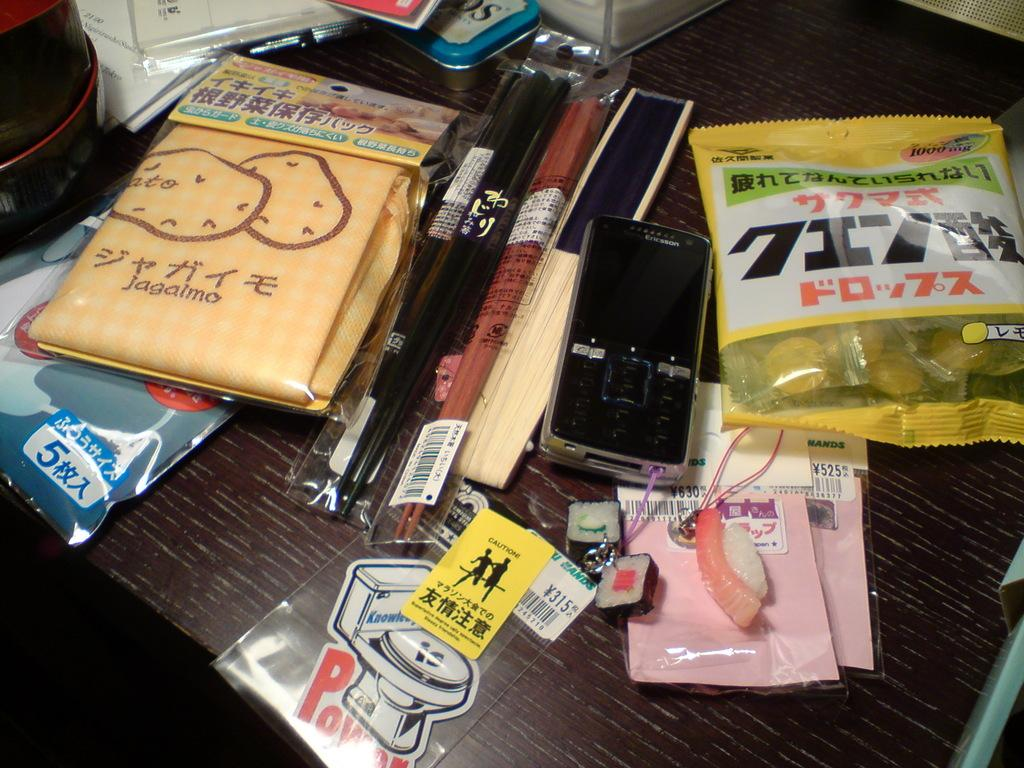<image>
Present a compact description of the photo's key features. a number of articles on a table, one of which has a picture of a toilet and the word pow at the bottom 